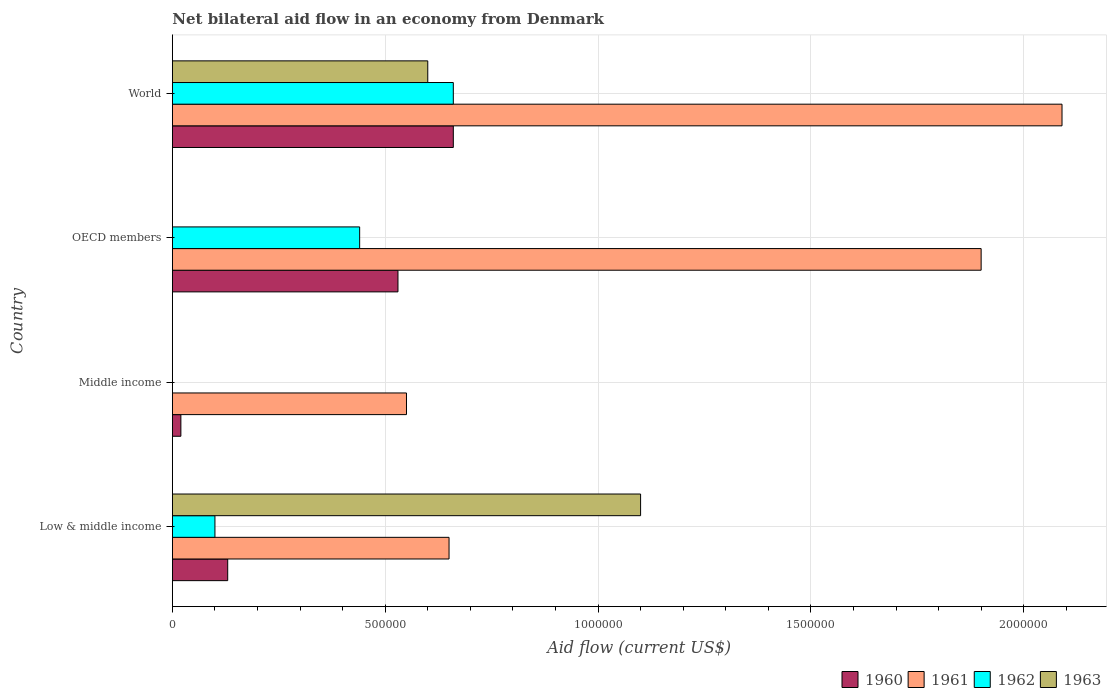How many groups of bars are there?
Make the answer very short. 4. Are the number of bars per tick equal to the number of legend labels?
Your response must be concise. No. How many bars are there on the 2nd tick from the bottom?
Ensure brevity in your answer.  2. What is the label of the 4th group of bars from the top?
Provide a succinct answer. Low & middle income. What is the net bilateral aid flow in 1961 in World?
Your response must be concise. 2.09e+06. Across all countries, what is the maximum net bilateral aid flow in 1960?
Your answer should be compact. 6.60e+05. What is the total net bilateral aid flow in 1962 in the graph?
Provide a succinct answer. 1.20e+06. What is the difference between the net bilateral aid flow in 1960 in Middle income and that in World?
Offer a very short reply. -6.40e+05. What is the difference between the net bilateral aid flow in 1961 in OECD members and the net bilateral aid flow in 1960 in Low & middle income?
Provide a short and direct response. 1.77e+06. What is the average net bilateral aid flow in 1961 per country?
Offer a terse response. 1.30e+06. What is the difference between the net bilateral aid flow in 1961 and net bilateral aid flow in 1960 in Middle income?
Ensure brevity in your answer.  5.30e+05. In how many countries, is the net bilateral aid flow in 1963 greater than 500000 US$?
Provide a short and direct response. 2. What is the ratio of the net bilateral aid flow in 1961 in Low & middle income to that in OECD members?
Provide a succinct answer. 0.34. Is the net bilateral aid flow in 1961 in OECD members less than that in World?
Keep it short and to the point. Yes. What is the difference between the highest and the second highest net bilateral aid flow in 1962?
Offer a very short reply. 2.20e+05. In how many countries, is the net bilateral aid flow in 1962 greater than the average net bilateral aid flow in 1962 taken over all countries?
Offer a very short reply. 2. Is it the case that in every country, the sum of the net bilateral aid flow in 1962 and net bilateral aid flow in 1963 is greater than the net bilateral aid flow in 1960?
Provide a succinct answer. No. Are all the bars in the graph horizontal?
Offer a terse response. Yes. What is the difference between two consecutive major ticks on the X-axis?
Provide a succinct answer. 5.00e+05. Are the values on the major ticks of X-axis written in scientific E-notation?
Offer a very short reply. No. How many legend labels are there?
Provide a succinct answer. 4. How are the legend labels stacked?
Your answer should be very brief. Horizontal. What is the title of the graph?
Offer a very short reply. Net bilateral aid flow in an economy from Denmark. What is the label or title of the Y-axis?
Offer a very short reply. Country. What is the Aid flow (current US$) in 1960 in Low & middle income?
Your answer should be compact. 1.30e+05. What is the Aid flow (current US$) of 1961 in Low & middle income?
Keep it short and to the point. 6.50e+05. What is the Aid flow (current US$) in 1962 in Low & middle income?
Offer a very short reply. 1.00e+05. What is the Aid flow (current US$) of 1963 in Low & middle income?
Offer a very short reply. 1.10e+06. What is the Aid flow (current US$) of 1960 in Middle income?
Your response must be concise. 2.00e+04. What is the Aid flow (current US$) of 1963 in Middle income?
Provide a succinct answer. 0. What is the Aid flow (current US$) in 1960 in OECD members?
Offer a very short reply. 5.30e+05. What is the Aid flow (current US$) in 1961 in OECD members?
Your answer should be compact. 1.90e+06. What is the Aid flow (current US$) of 1962 in OECD members?
Offer a very short reply. 4.40e+05. What is the Aid flow (current US$) of 1960 in World?
Your response must be concise. 6.60e+05. What is the Aid flow (current US$) in 1961 in World?
Ensure brevity in your answer.  2.09e+06. Across all countries, what is the maximum Aid flow (current US$) of 1961?
Provide a short and direct response. 2.09e+06. Across all countries, what is the maximum Aid flow (current US$) in 1962?
Keep it short and to the point. 6.60e+05. Across all countries, what is the maximum Aid flow (current US$) in 1963?
Provide a succinct answer. 1.10e+06. Across all countries, what is the minimum Aid flow (current US$) in 1960?
Provide a short and direct response. 2.00e+04. Across all countries, what is the minimum Aid flow (current US$) in 1961?
Make the answer very short. 5.50e+05. Across all countries, what is the minimum Aid flow (current US$) in 1963?
Provide a short and direct response. 0. What is the total Aid flow (current US$) in 1960 in the graph?
Give a very brief answer. 1.34e+06. What is the total Aid flow (current US$) of 1961 in the graph?
Provide a short and direct response. 5.19e+06. What is the total Aid flow (current US$) in 1962 in the graph?
Your answer should be compact. 1.20e+06. What is the total Aid flow (current US$) of 1963 in the graph?
Your response must be concise. 1.70e+06. What is the difference between the Aid flow (current US$) in 1960 in Low & middle income and that in OECD members?
Offer a very short reply. -4.00e+05. What is the difference between the Aid flow (current US$) of 1961 in Low & middle income and that in OECD members?
Provide a short and direct response. -1.25e+06. What is the difference between the Aid flow (current US$) in 1962 in Low & middle income and that in OECD members?
Offer a very short reply. -3.40e+05. What is the difference between the Aid flow (current US$) in 1960 in Low & middle income and that in World?
Offer a very short reply. -5.30e+05. What is the difference between the Aid flow (current US$) of 1961 in Low & middle income and that in World?
Offer a very short reply. -1.44e+06. What is the difference between the Aid flow (current US$) in 1962 in Low & middle income and that in World?
Your response must be concise. -5.60e+05. What is the difference between the Aid flow (current US$) of 1960 in Middle income and that in OECD members?
Keep it short and to the point. -5.10e+05. What is the difference between the Aid flow (current US$) in 1961 in Middle income and that in OECD members?
Make the answer very short. -1.35e+06. What is the difference between the Aid flow (current US$) of 1960 in Middle income and that in World?
Offer a very short reply. -6.40e+05. What is the difference between the Aid flow (current US$) in 1961 in Middle income and that in World?
Ensure brevity in your answer.  -1.54e+06. What is the difference between the Aid flow (current US$) of 1960 in OECD members and that in World?
Offer a terse response. -1.30e+05. What is the difference between the Aid flow (current US$) of 1960 in Low & middle income and the Aid flow (current US$) of 1961 in Middle income?
Keep it short and to the point. -4.20e+05. What is the difference between the Aid flow (current US$) in 1960 in Low & middle income and the Aid flow (current US$) in 1961 in OECD members?
Your answer should be compact. -1.77e+06. What is the difference between the Aid flow (current US$) in 1960 in Low & middle income and the Aid flow (current US$) in 1962 in OECD members?
Make the answer very short. -3.10e+05. What is the difference between the Aid flow (current US$) of 1961 in Low & middle income and the Aid flow (current US$) of 1962 in OECD members?
Your response must be concise. 2.10e+05. What is the difference between the Aid flow (current US$) of 1960 in Low & middle income and the Aid flow (current US$) of 1961 in World?
Keep it short and to the point. -1.96e+06. What is the difference between the Aid flow (current US$) in 1960 in Low & middle income and the Aid flow (current US$) in 1962 in World?
Ensure brevity in your answer.  -5.30e+05. What is the difference between the Aid flow (current US$) in 1960 in Low & middle income and the Aid flow (current US$) in 1963 in World?
Give a very brief answer. -4.70e+05. What is the difference between the Aid flow (current US$) in 1962 in Low & middle income and the Aid flow (current US$) in 1963 in World?
Keep it short and to the point. -5.00e+05. What is the difference between the Aid flow (current US$) in 1960 in Middle income and the Aid flow (current US$) in 1961 in OECD members?
Keep it short and to the point. -1.88e+06. What is the difference between the Aid flow (current US$) in 1960 in Middle income and the Aid flow (current US$) in 1962 in OECD members?
Give a very brief answer. -4.20e+05. What is the difference between the Aid flow (current US$) in 1960 in Middle income and the Aid flow (current US$) in 1961 in World?
Ensure brevity in your answer.  -2.07e+06. What is the difference between the Aid flow (current US$) of 1960 in Middle income and the Aid flow (current US$) of 1962 in World?
Provide a succinct answer. -6.40e+05. What is the difference between the Aid flow (current US$) in 1960 in Middle income and the Aid flow (current US$) in 1963 in World?
Your answer should be very brief. -5.80e+05. What is the difference between the Aid flow (current US$) in 1961 in Middle income and the Aid flow (current US$) in 1962 in World?
Keep it short and to the point. -1.10e+05. What is the difference between the Aid flow (current US$) in 1961 in Middle income and the Aid flow (current US$) in 1963 in World?
Offer a terse response. -5.00e+04. What is the difference between the Aid flow (current US$) in 1960 in OECD members and the Aid flow (current US$) in 1961 in World?
Your answer should be very brief. -1.56e+06. What is the difference between the Aid flow (current US$) of 1960 in OECD members and the Aid flow (current US$) of 1963 in World?
Keep it short and to the point. -7.00e+04. What is the difference between the Aid flow (current US$) in 1961 in OECD members and the Aid flow (current US$) in 1962 in World?
Make the answer very short. 1.24e+06. What is the difference between the Aid flow (current US$) of 1961 in OECD members and the Aid flow (current US$) of 1963 in World?
Give a very brief answer. 1.30e+06. What is the difference between the Aid flow (current US$) of 1962 in OECD members and the Aid flow (current US$) of 1963 in World?
Your answer should be very brief. -1.60e+05. What is the average Aid flow (current US$) of 1960 per country?
Keep it short and to the point. 3.35e+05. What is the average Aid flow (current US$) of 1961 per country?
Offer a very short reply. 1.30e+06. What is the average Aid flow (current US$) of 1962 per country?
Your answer should be very brief. 3.00e+05. What is the average Aid flow (current US$) in 1963 per country?
Offer a terse response. 4.25e+05. What is the difference between the Aid flow (current US$) of 1960 and Aid flow (current US$) of 1961 in Low & middle income?
Offer a very short reply. -5.20e+05. What is the difference between the Aid flow (current US$) of 1960 and Aid flow (current US$) of 1963 in Low & middle income?
Your answer should be compact. -9.70e+05. What is the difference between the Aid flow (current US$) in 1961 and Aid flow (current US$) in 1962 in Low & middle income?
Give a very brief answer. 5.50e+05. What is the difference between the Aid flow (current US$) in 1961 and Aid flow (current US$) in 1963 in Low & middle income?
Ensure brevity in your answer.  -4.50e+05. What is the difference between the Aid flow (current US$) in 1960 and Aid flow (current US$) in 1961 in Middle income?
Ensure brevity in your answer.  -5.30e+05. What is the difference between the Aid flow (current US$) of 1960 and Aid flow (current US$) of 1961 in OECD members?
Give a very brief answer. -1.37e+06. What is the difference between the Aid flow (current US$) of 1960 and Aid flow (current US$) of 1962 in OECD members?
Provide a short and direct response. 9.00e+04. What is the difference between the Aid flow (current US$) in 1961 and Aid flow (current US$) in 1962 in OECD members?
Provide a succinct answer. 1.46e+06. What is the difference between the Aid flow (current US$) in 1960 and Aid flow (current US$) in 1961 in World?
Provide a short and direct response. -1.43e+06. What is the difference between the Aid flow (current US$) in 1960 and Aid flow (current US$) in 1962 in World?
Your answer should be compact. 0. What is the difference between the Aid flow (current US$) of 1960 and Aid flow (current US$) of 1963 in World?
Your answer should be compact. 6.00e+04. What is the difference between the Aid flow (current US$) in 1961 and Aid flow (current US$) in 1962 in World?
Your answer should be compact. 1.43e+06. What is the difference between the Aid flow (current US$) of 1961 and Aid flow (current US$) of 1963 in World?
Keep it short and to the point. 1.49e+06. What is the ratio of the Aid flow (current US$) in 1961 in Low & middle income to that in Middle income?
Provide a succinct answer. 1.18. What is the ratio of the Aid flow (current US$) in 1960 in Low & middle income to that in OECD members?
Provide a succinct answer. 0.25. What is the ratio of the Aid flow (current US$) of 1961 in Low & middle income to that in OECD members?
Your response must be concise. 0.34. What is the ratio of the Aid flow (current US$) of 1962 in Low & middle income to that in OECD members?
Offer a very short reply. 0.23. What is the ratio of the Aid flow (current US$) in 1960 in Low & middle income to that in World?
Provide a succinct answer. 0.2. What is the ratio of the Aid flow (current US$) in 1961 in Low & middle income to that in World?
Keep it short and to the point. 0.31. What is the ratio of the Aid flow (current US$) of 1962 in Low & middle income to that in World?
Your response must be concise. 0.15. What is the ratio of the Aid flow (current US$) in 1963 in Low & middle income to that in World?
Your response must be concise. 1.83. What is the ratio of the Aid flow (current US$) in 1960 in Middle income to that in OECD members?
Make the answer very short. 0.04. What is the ratio of the Aid flow (current US$) of 1961 in Middle income to that in OECD members?
Your answer should be very brief. 0.29. What is the ratio of the Aid flow (current US$) of 1960 in Middle income to that in World?
Your response must be concise. 0.03. What is the ratio of the Aid flow (current US$) in 1961 in Middle income to that in World?
Your answer should be compact. 0.26. What is the ratio of the Aid flow (current US$) in 1960 in OECD members to that in World?
Your answer should be compact. 0.8. What is the ratio of the Aid flow (current US$) in 1961 in OECD members to that in World?
Your response must be concise. 0.91. What is the difference between the highest and the lowest Aid flow (current US$) in 1960?
Ensure brevity in your answer.  6.40e+05. What is the difference between the highest and the lowest Aid flow (current US$) in 1961?
Give a very brief answer. 1.54e+06. What is the difference between the highest and the lowest Aid flow (current US$) of 1962?
Offer a terse response. 6.60e+05. What is the difference between the highest and the lowest Aid flow (current US$) in 1963?
Provide a short and direct response. 1.10e+06. 